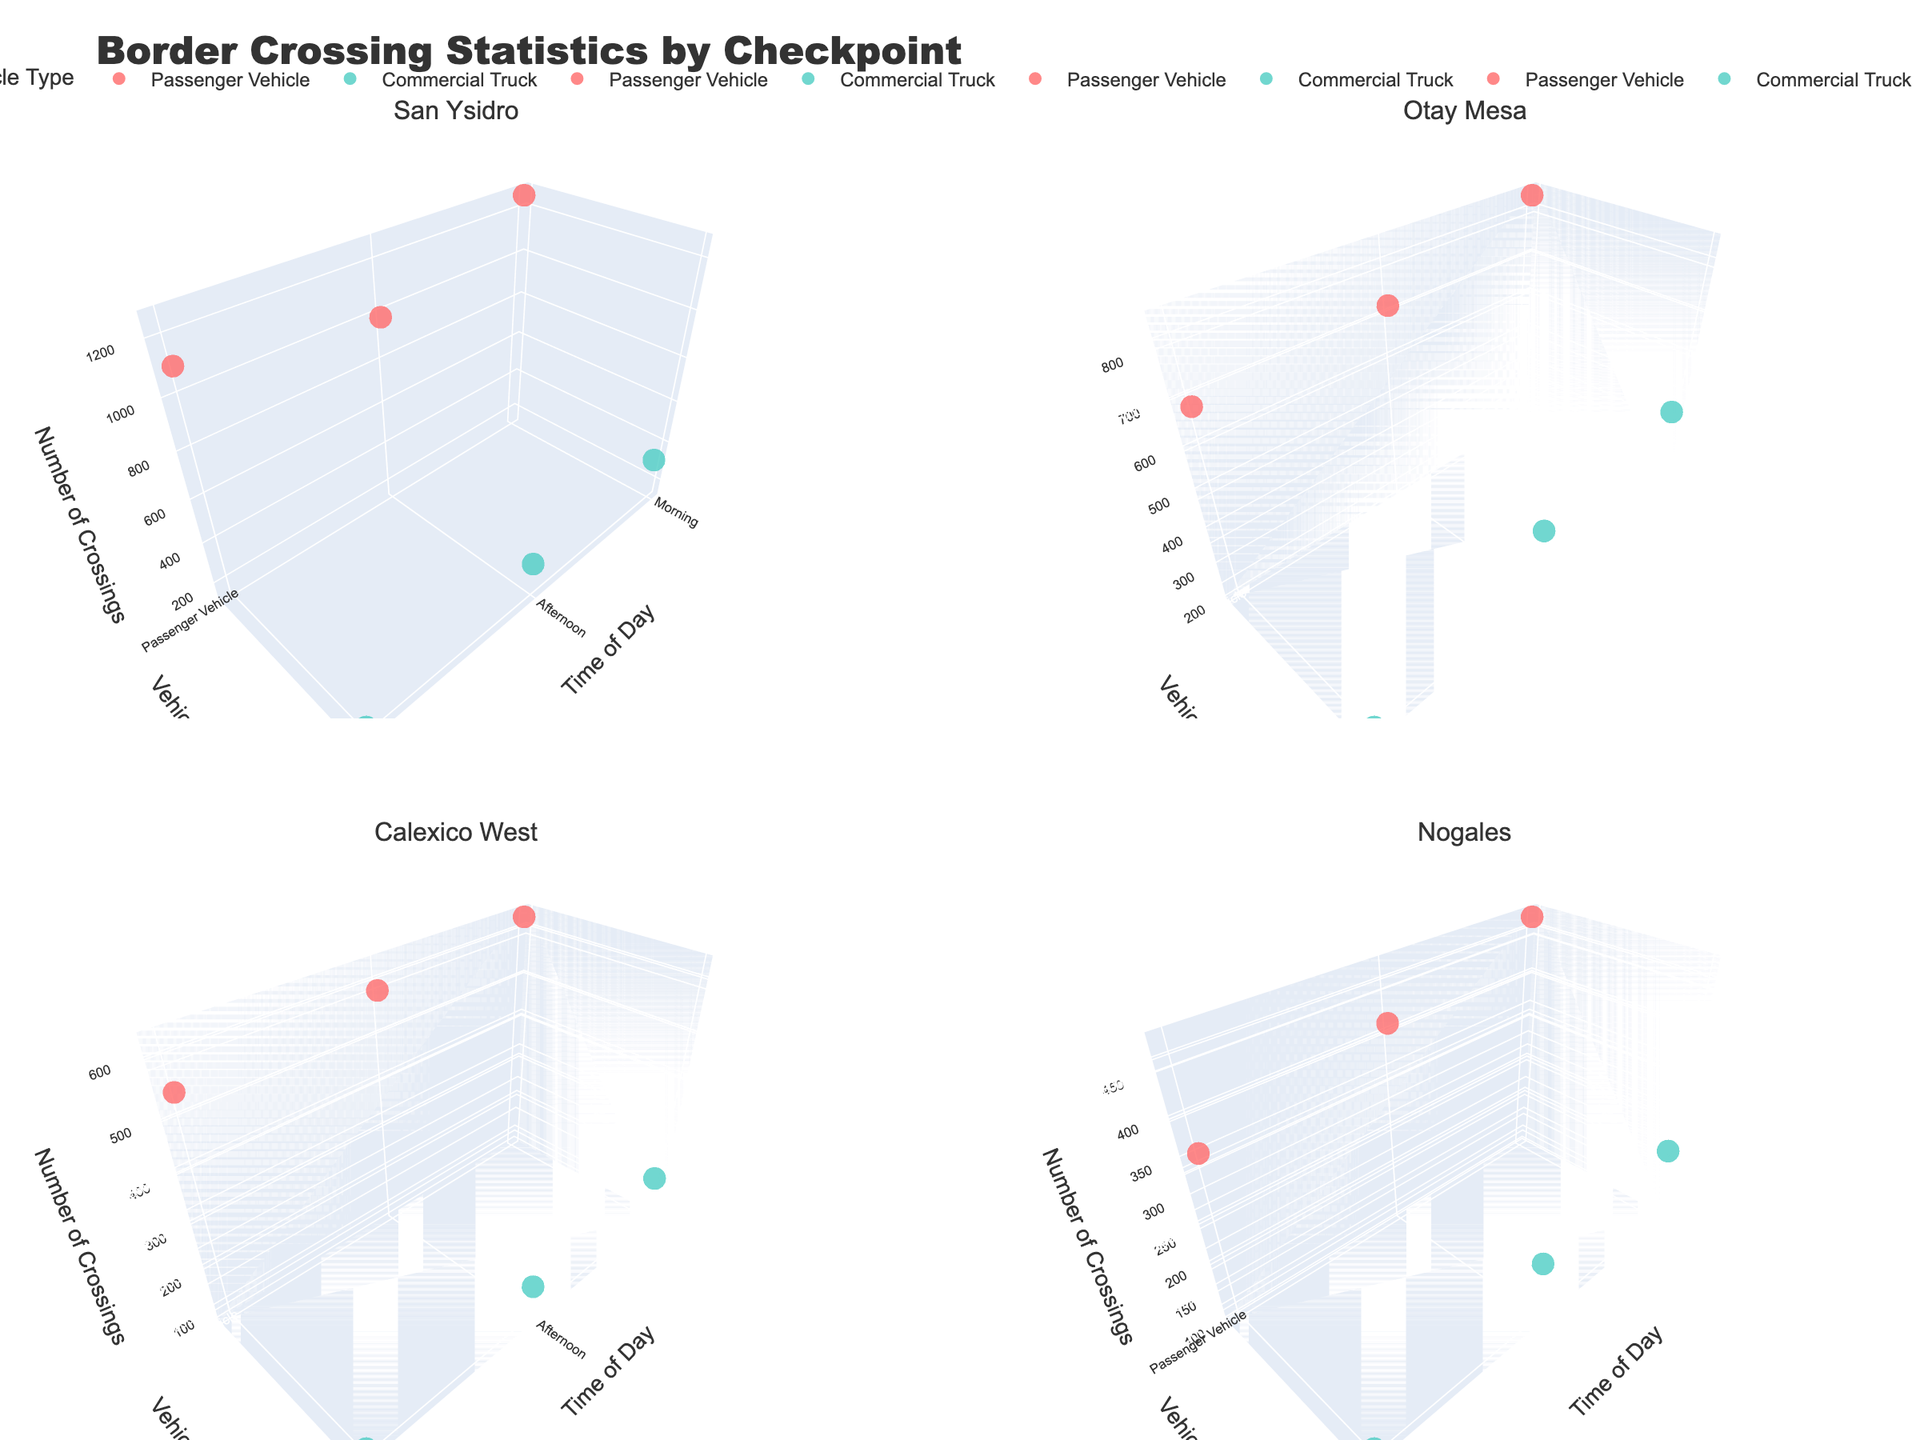Which checkpoint has the highest number of passenger vehicle crossings in the morning? To find the checkpoint with the highest number of passenger vehicle crossings in the morning, look at the morning data points for passenger vehicles in each subplot. For San Ysidro, it's 1250; for Otay Mesa, it's 850; for Calexico West, it's 620; for Nogales, it's 480. Hence, San Ysidro has the highest number.
Answer: San Ysidro How do the evening crossings for commercial trucks at Otay Mesa compare with those at San Ysidro? Look at the evening data points for commercial trucks at Otay Mesa and San Ysidro. Otay Mesa has 210 crossings, and San Ysidro has 150 crossings. Comparatively, Otay Mesa has more crossings.
Answer: Otay Mesa has more What is the total number of crossings for commercial trucks at Otay Mesa across all times of day? Calculate the sum of morning, afternoon, and evening crossings for commercial trucks at Otay Mesa. The values are 450 (morning) + 380 (afternoon) + 210 (evening) = 1040.
Answer: 1040 Which time of day has the least number of crossings for passenger vehicles at Calexico West? Referring to the subplot for Calexico West, the crossings for passenger vehicles are 620 (morning), 580 (afternoon), and 540 (evening). Thus, the evening has the least number.
Answer: Evening Are there more commercial truck crossings in the morning or afternoon at San Ysidro? Look at the morning and afternoon data points for commercial trucks at San Ysidro. Morning has 320 crossings, and afternoon has 280 crossings. Hence, morning has more crossings.
Answer: Morning Which checkpoint shows the most balanced distribution of crossings throughout the day for commercial trucks? Examine the spread of data points for commercial trucks across morning, afternoon, and evening at each checkpoint. Otay Mesa has relatively close values (450, 380, 210), compared to others.
Answer: Otay Mesa What is the difference in passenger vehicle crossings between morning and evening at Nogales? Locate the number of crossings for passenger vehicles in the morning and evening at Nogales, which are 480 and 350, respectively. The difference is 480 - 350 = 130.
Answer: 130 At which checkpoint is the discrepancy between passenger vehicle and commercial truck crossings the greatest in the afternoon? For each checkpoint in the afternoon, subtract commercial truck crossings from passenger vehicle crossings: 
San Ysidro: 980 - 280 = 700
Otay Mesa: 720 - 380 = 340
Calexico West: 580 - 150 = 430
Nogales: 410 - 190 = 220
San Ysidro has the greatest discrepancy.
Answer: San Ysidro 